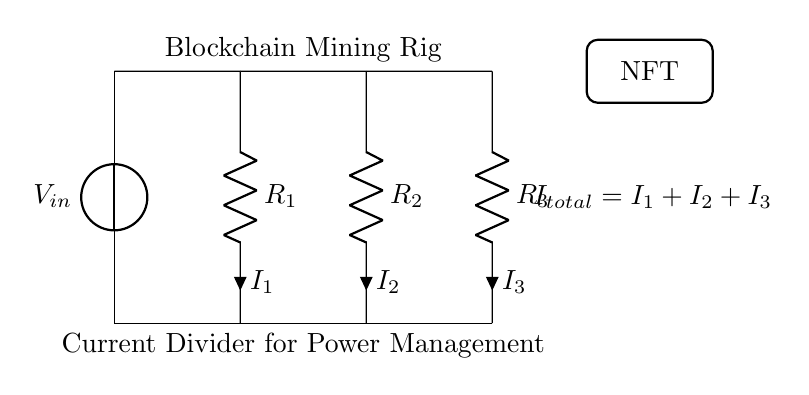What is the input voltage in the circuit? The circuit shows a voltage source marked as V in, indicating the input voltage.
Answer: V in How many resistors are present in the circuit? There are three resistors labeled R1, R2, and R3, which can be counted directly from the diagram.
Answer: 3 What is the total current in the circuit? The total current is represented in the circuit as I total, which is the sum of the currents I1, I2, and I3 flowing through the resistors.
Answer: I total Which resistor has the highest current passing through it? Without specific values, we cannot definitively say which resistor will have the highest current; however, current divides inversely with resistance, so the smallest resistance will have the highest current.
Answer: Smallest resistance What does the block labeled "NFT" indicate? The block labeled "NFT" represents a decorative element related to the digital art theme, indicating a mix of technology and art in the context of blockchain mining.
Answer: NFT 